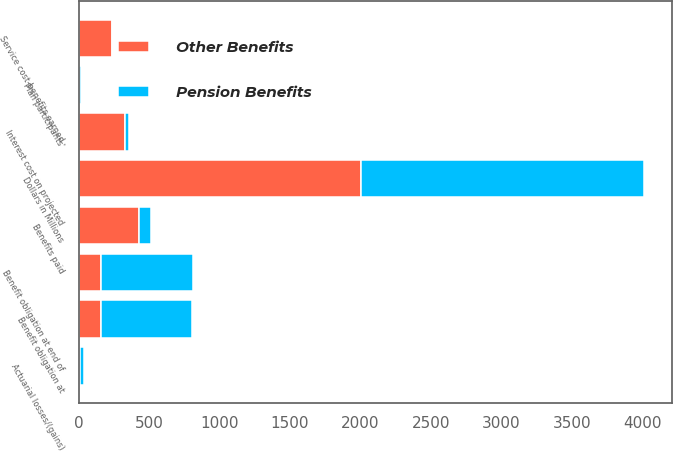Convert chart to OTSL. <chart><loc_0><loc_0><loc_500><loc_500><stacked_bar_chart><ecel><fcel>Dollars in Millions<fcel>Benefit obligation at<fcel>Service cost-benefits earned<fcel>Interest cost on projected<fcel>Plan participants'<fcel>Actuarial losses/(gains)<fcel>Benefits paid<fcel>Benefit obligation at end of<nl><fcel>Other Benefits<fcel>2006<fcel>159.5<fcel>238<fcel>326<fcel>3<fcel>10<fcel>432<fcel>159.5<nl><fcel>Pension Benefits<fcel>2006<fcel>643<fcel>9<fcel>34<fcel>12<fcel>27<fcel>81<fcel>651<nl></chart> 